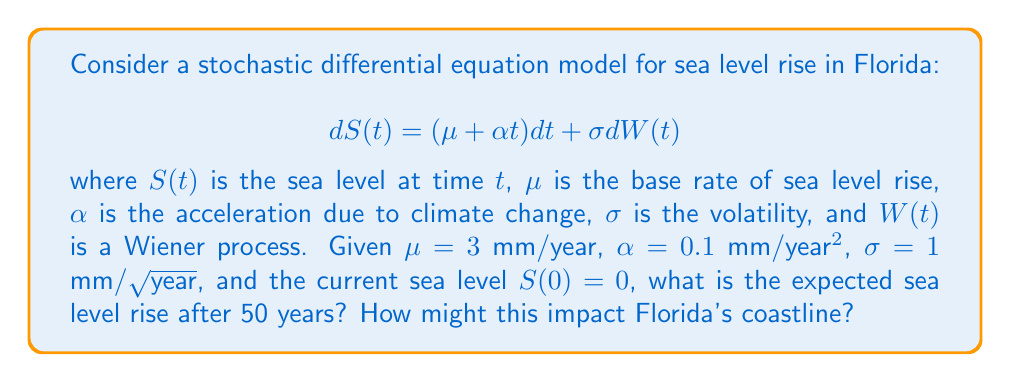Can you solve this math problem? To solve this problem, we need to follow these steps:

1) The expected value of the Wiener process $E[W(t)] = 0$, so we can ignore the stochastic term when calculating the expected sea level.

2) The deterministic part of the SDE can be integrated:

   $$E[S(t)] = \int_0^t (\mu + \alpha s)ds = \mu t + \frac{1}{2}\alpha t^2$$

3) Substituting the given values and $t = 50$ years:

   $$E[S(50)] = 3 \cdot 50 + \frac{1}{2} \cdot 0.1 \cdot 50^2$$
   
   $$E[S(50)] = 150 + 125 = 275 \text{ mm}$$

4) Convert to meters: 275 mm = 0.275 m

5) Impact on Florida's coastline:
   - A sea level rise of 0.275 m could lead to significant coastal erosion.
   - Low-lying areas might experience more frequent flooding.
   - Salt water intrusion could affect freshwater aquifers.
   - Beaches and coastal ecosystems could be severely impacted.
   - Coastal infrastructure and properties would be at increased risk.

This model demonstrates the urgent need for climate action to protect Florida's vulnerable coastline.
Answer: 0.275 m sea level rise, leading to coastal erosion, flooding, and ecosystem damage. 